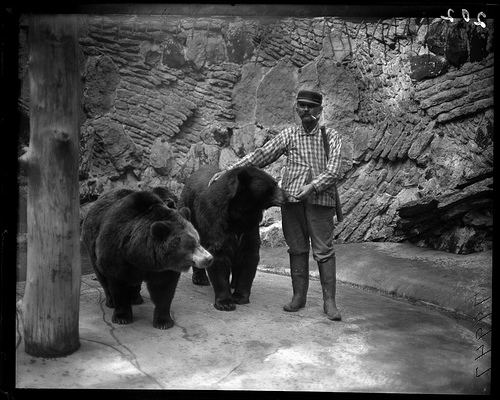<image>Which bear is wearing a striped sweater? None of the bears are wearing a striped sweater. Which bear has an open mouth? It's ambiguous to determine which bear has an open mouth. Which bear is wearing a striped sweater? None of the bears are wearing a striped sweater. Which bear has an open mouth? I don't know which bear has an open mouth. 